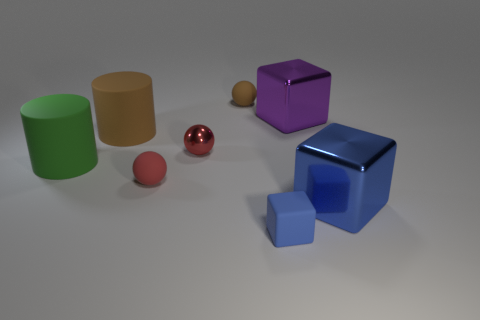The blue block on the right side of the blue block that is left of the big purple block is made of what material?
Provide a succinct answer. Metal. What is the material of the cube that is right of the large purple cube?
Provide a succinct answer. Metal. What number of other objects are the same shape as the green rubber thing?
Make the answer very short. 1. The big cube that is behind the blue metallic object that is right of the brown sphere on the left side of the small blue matte thing is made of what material?
Your answer should be very brief. Metal. There is a red metallic thing; are there any blue metallic blocks on the right side of it?
Provide a short and direct response. Yes. What shape is the green object that is the same size as the purple block?
Ensure brevity in your answer.  Cylinder. Is the material of the big purple block the same as the small cube?
Your answer should be compact. No. How many rubber things are either large red blocks or brown objects?
Give a very brief answer. 2. There is a big shiny object that is the same color as the small matte cube; what is its shape?
Your answer should be compact. Cube. There is a big metallic cube that is in front of the brown cylinder; is its color the same as the small block?
Offer a terse response. Yes. 